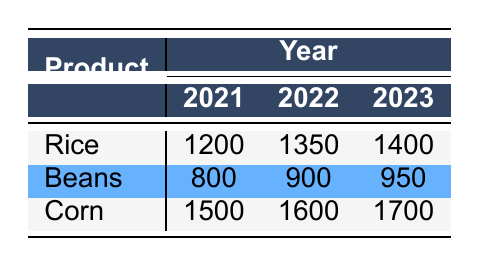What was the production quantity of Beans in 2022? Looking at the table, we find the row for Beans, and under the column for the year 2022, the quantity is listed as 900.
Answer: 900 Which agricultural product showed the highest production in 2023? Referring to the year 2023 row in the table, we see that Corn has the highest quantity of 1700, compared to Rice (1400) and Beans (950).
Answer: Corn What is the difference in production quantity of Rice between 2021 and 2023? The quantity of Rice in 2021 is 1200, and in 2023 it is 1400. To find the difference, we subtract: 1400 - 1200 = 200.
Answer: 200 Is the quantity of Corn in 2022 greater than that of Beans in the same year? According to the table, the quantity of Corn in 2022 is 1600, while the quantity of Beans is 900. Since 1600 is greater than 900, the statement is true.
Answer: Yes What is the total production quantity for all products in 2021? We add the quantities of all products for the year 2021: Rice (1200) + Beans (800) + Corn (1500) = 3500.
Answer: 3500 How much did the production of Beans increase from 2021 to 2023? The quantity of Beans in 2021 is 800 and in 2023 it is 950. The increase is calculated as: 950 - 800 = 150.
Answer: 150 Which product had the least increase in production from 2021 to 2022? The increases are: Rice (1350 - 1200 = 150), Beans (900 - 800 = 100), and Corn (1600 - 1500 = 100). Both Beans and Corn had the least increase of 100.
Answer: Beans and Corn What is the average production quantity of Corn over the three years? The quantities for Corn are: 1500 (2021), 1600 (2022), and 1700 (2023). To find the average, we sum these: 1500 + 1600 + 1700 = 4800 and divide by 3, which gives us: 4800 / 3 = 1600.
Answer: 1600 How many products have a production quantity greater than 900 in 2022? In 2022, the quantities are: Rice (1350), Beans (900), and Corn (1600). Only Rice and Corn have quantities greater than 900, making it 2 products.
Answer: 2 